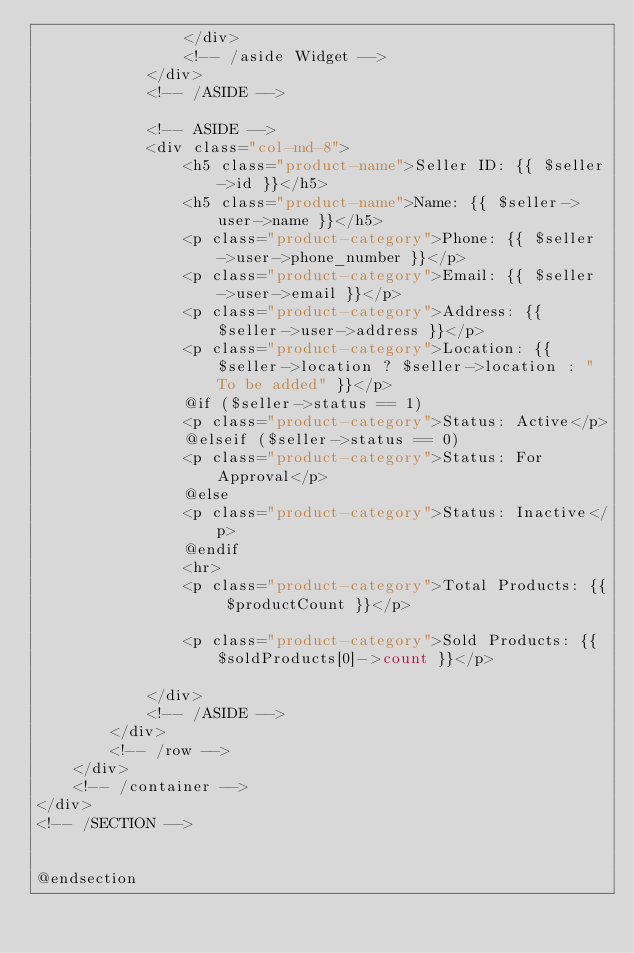Convert code to text. <code><loc_0><loc_0><loc_500><loc_500><_PHP_>                </div>
                <!-- /aside Widget -->
            </div>
            <!-- /ASIDE -->

            <!-- ASIDE -->
            <div class="col-md-8">
                <h5 class="product-name">Seller ID: {{ $seller->id }}</h5>
                <h5 class="product-name">Name: {{ $seller->user->name }}</h5>
                <p class="product-category">Phone: {{ $seller->user->phone_number }}</p>
                <p class="product-category">Email: {{ $seller->user->email }}</p>
                <p class="product-category">Address: {{ $seller->user->address }}</p>
                <p class="product-category">Location: {{ $seller->location ? $seller->location : "To be added" }}</p>
                @if ($seller->status == 1)
                <p class="product-category">Status: Active</p>
                @elseif ($seller->status == 0)
                <p class="product-category">Status: For Approval</p>
                @else
                <p class="product-category">Status: Inactive</p>
                @endif
                <hr>
                <p class="product-category">Total Products: {{ $productCount }}</p>

                <p class="product-category">Sold Products: {{ $soldProducts[0]->count }}</p>

            </div>
            <!-- /ASIDE -->
        </div>
        <!-- /row -->
    </div>
    <!-- /container -->
</div>
<!-- /SECTION -->


@endsection</code> 